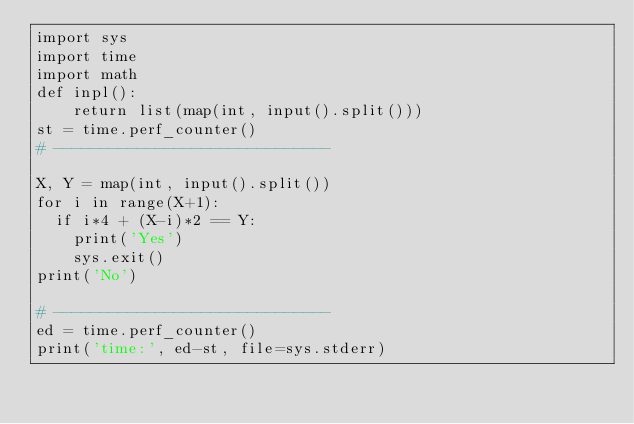<code> <loc_0><loc_0><loc_500><loc_500><_Python_>import sys
import time
import math
def inpl():
    return list(map(int, input().split()))
st = time.perf_counter()
# ------------------------------

X, Y = map(int, input().split())
for i in range(X+1):
	if i*4 + (X-i)*2 == Y:
		print('Yes')
		sys.exit()
print('No')

# ------------------------------
ed = time.perf_counter()
print('time:', ed-st, file=sys.stderr)
</code> 